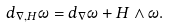Convert formula to latex. <formula><loc_0><loc_0><loc_500><loc_500>d _ { \nabla , H } \omega = d _ { \nabla } \omega + H \wedge \omega .</formula> 